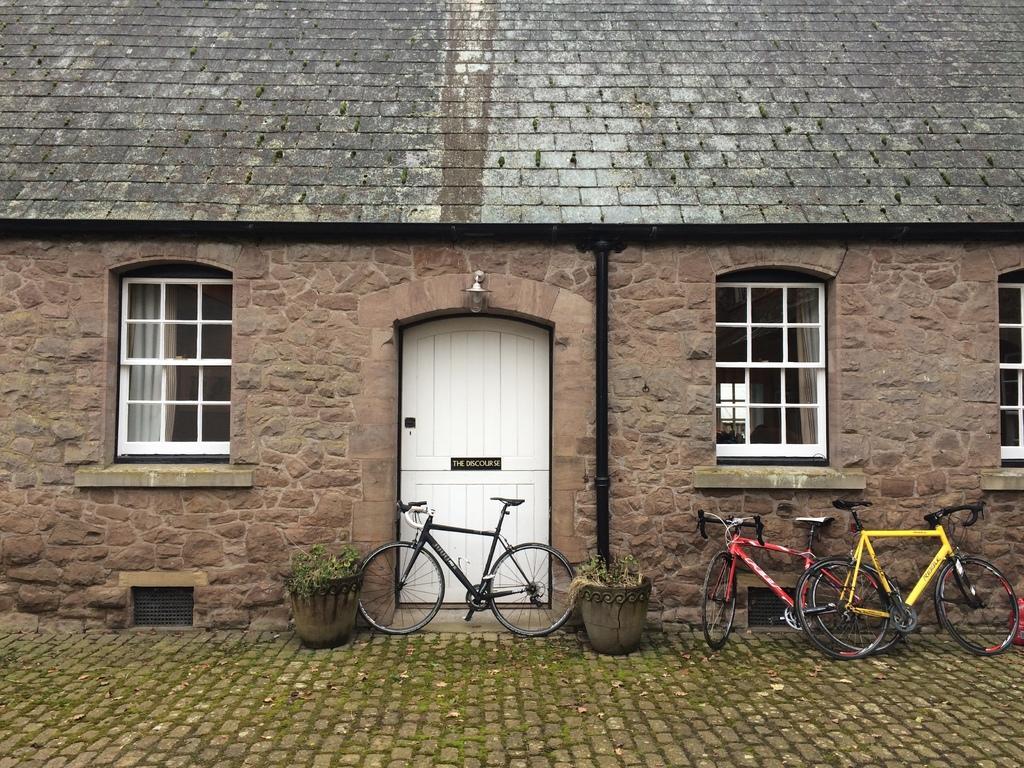Describe this image in one or two sentences. This picture is clicked outside. In the center there are some bicycles parked on the ground and we can see the house plants placed on the ground and there is a house and we can see a wall mounted lamp, white color door, windows and curtains. 